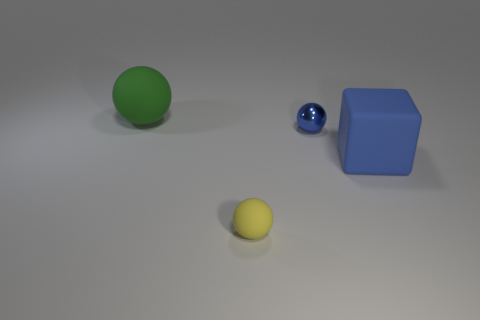Could this be a scene from a game involving these objects? Certainly, this could be an abstract representation of a game, where each object has its own set of rules or points associated with it. The different sizes and colors suggest they could serve distinct roles within the game, such as targets or pieces to be moved to specific zones. 